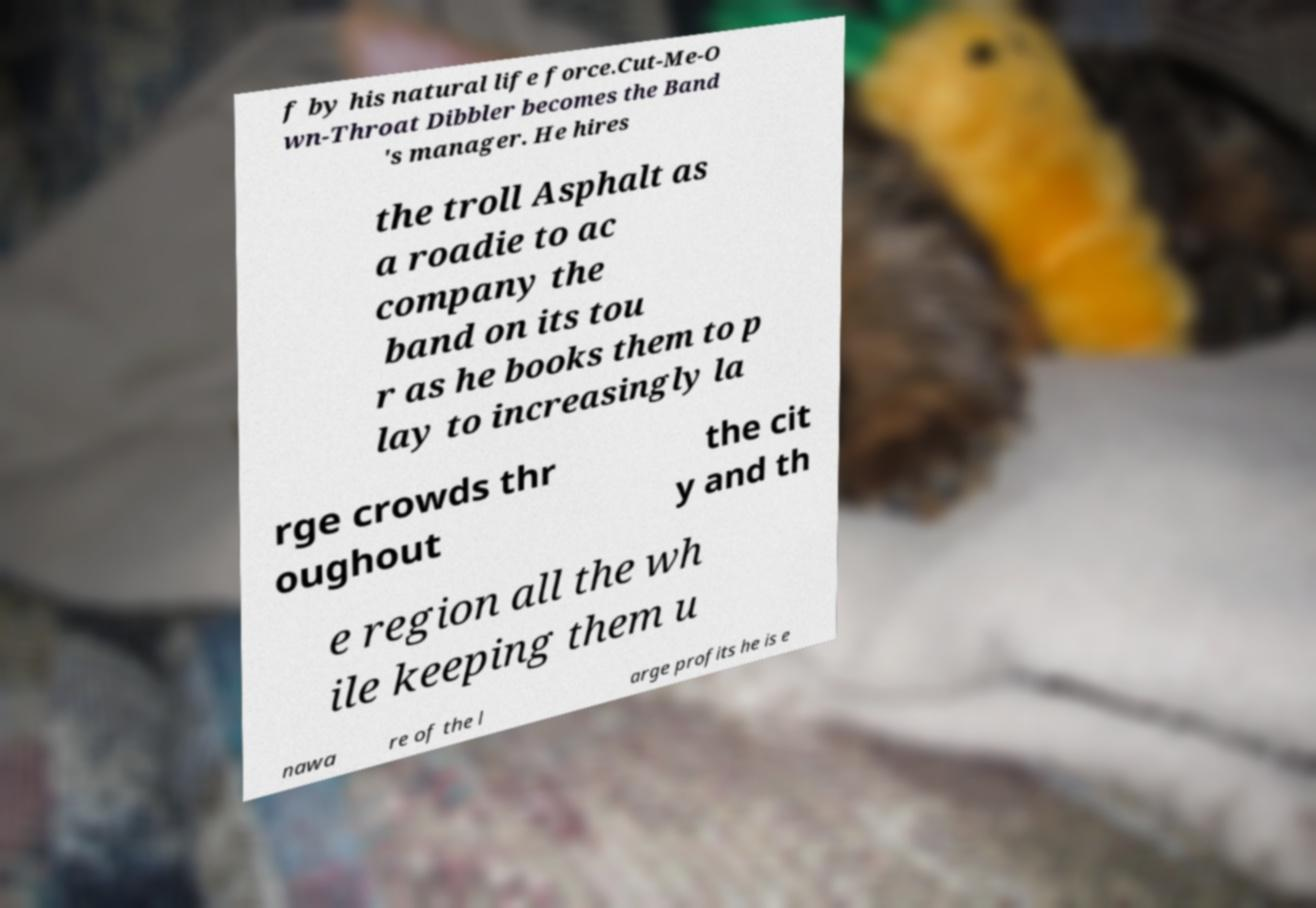Please identify and transcribe the text found in this image. f by his natural life force.Cut-Me-O wn-Throat Dibbler becomes the Band 's manager. He hires the troll Asphalt as a roadie to ac company the band on its tou r as he books them to p lay to increasingly la rge crowds thr oughout the cit y and th e region all the wh ile keeping them u nawa re of the l arge profits he is e 